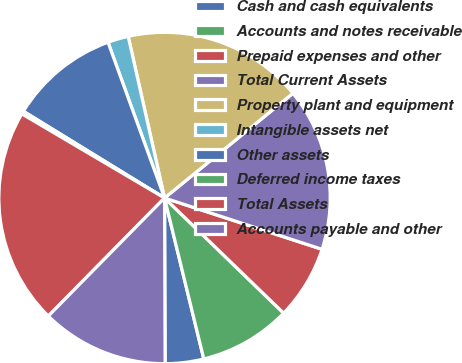Convert chart. <chart><loc_0><loc_0><loc_500><loc_500><pie_chart><fcel>Cash and cash equivalents<fcel>Accounts and notes receivable<fcel>Prepaid expenses and other<fcel>Total Current Assets<fcel>Property plant and equipment<fcel>Intangible assets net<fcel>Other assets<fcel>Deferred income taxes<fcel>Total Assets<fcel>Accounts payable and other<nl><fcel>3.75%<fcel>8.96%<fcel>7.22%<fcel>15.9%<fcel>17.63%<fcel>2.02%<fcel>10.69%<fcel>0.29%<fcel>21.1%<fcel>12.43%<nl></chart> 